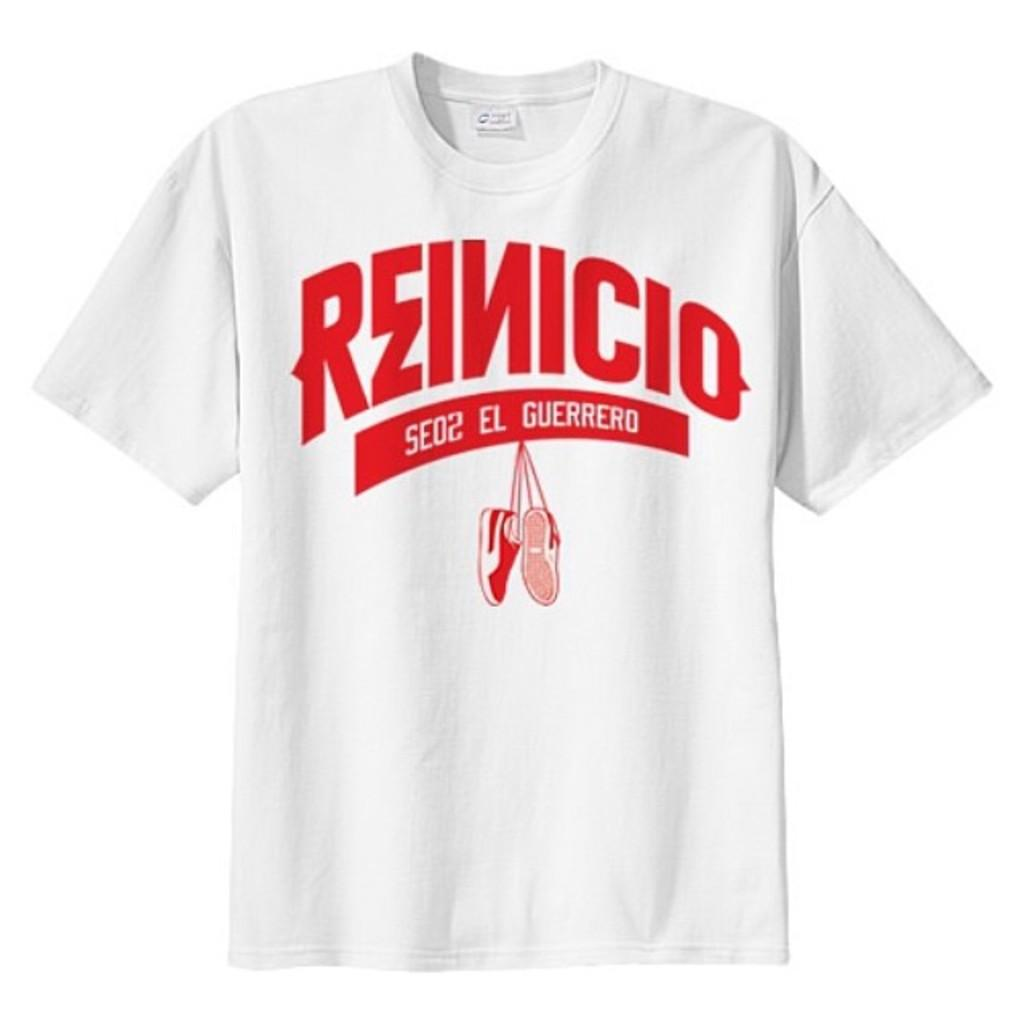Provide a one-sentence caption for the provided image. A shirt in spanish with big red letters spelling Reinicio. 